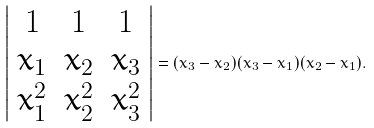Convert formula to latex. <formula><loc_0><loc_0><loc_500><loc_500>\left | { \begin{array} { c c c } { 1 } & { 1 } & { 1 } \\ { x _ { 1 } } & { x _ { 2 } } & { x _ { 3 } } \\ { x _ { 1 } ^ { 2 } } & { x _ { 2 } ^ { 2 } } & { x _ { 3 } ^ { 2 } } \end{array} } \right | = ( x _ { 3 } - x _ { 2 } ) ( x _ { 3 } - x _ { 1 } ) ( x _ { 2 } - x _ { 1 } ) .</formula> 